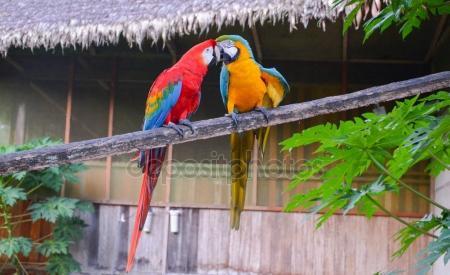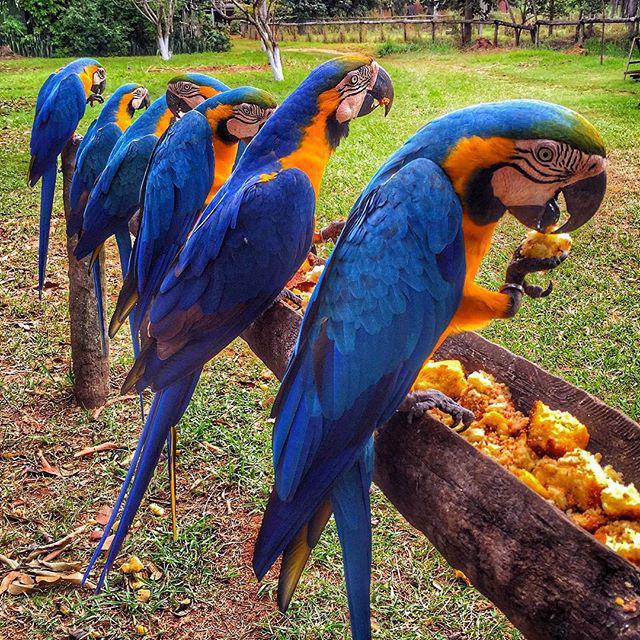The first image is the image on the left, the second image is the image on the right. Evaluate the accuracy of this statement regarding the images: "One of the birds in the right image has its wings spread.". Is it true? Answer yes or no. No. 